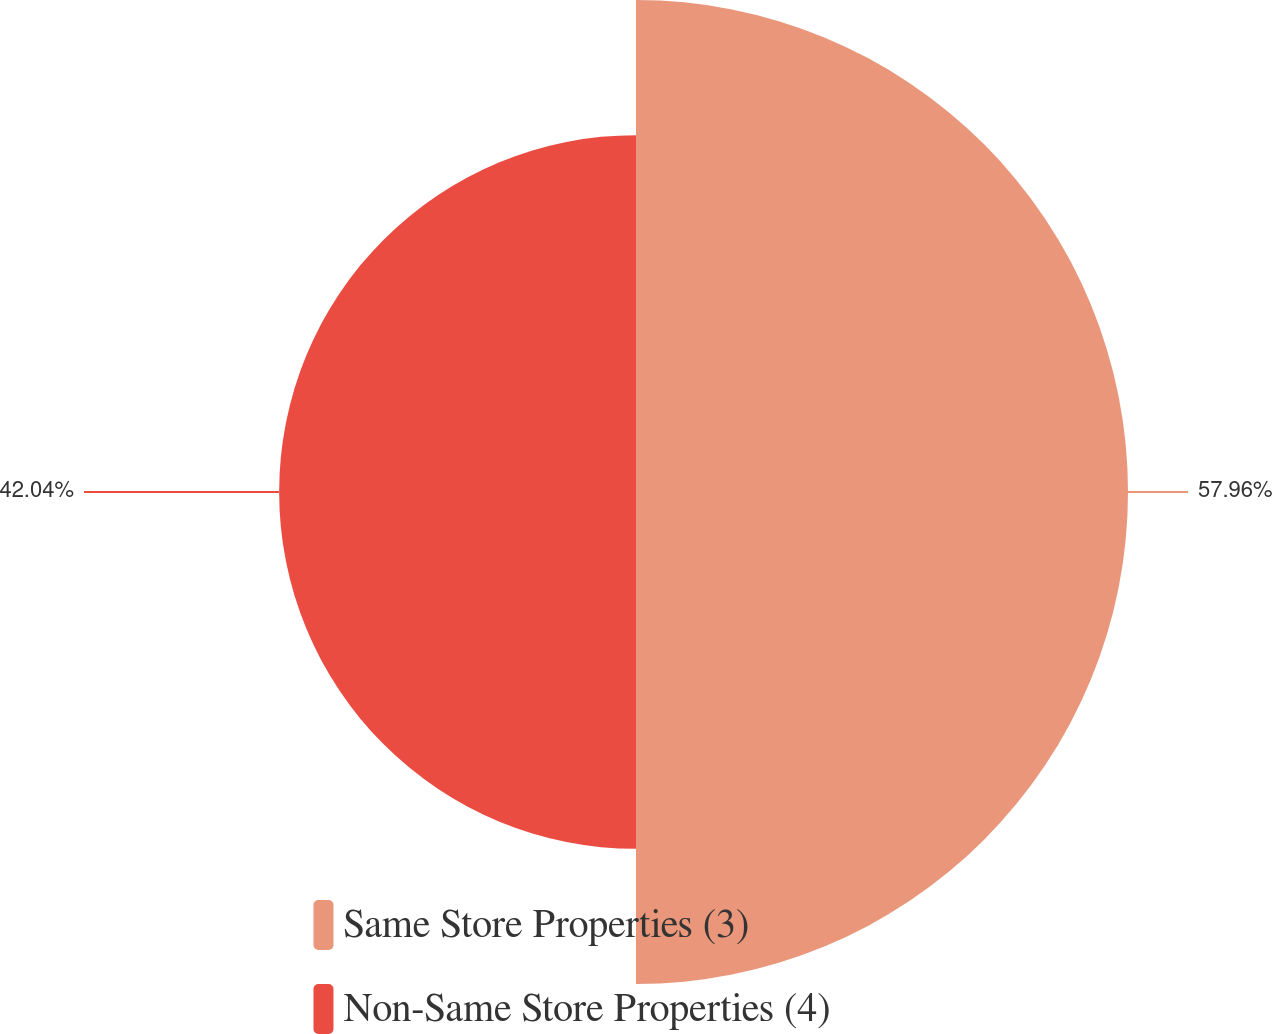<chart> <loc_0><loc_0><loc_500><loc_500><pie_chart><fcel>Same Store Properties (3)<fcel>Non-Same Store Properties (4)<nl><fcel>57.96%<fcel>42.04%<nl></chart> 